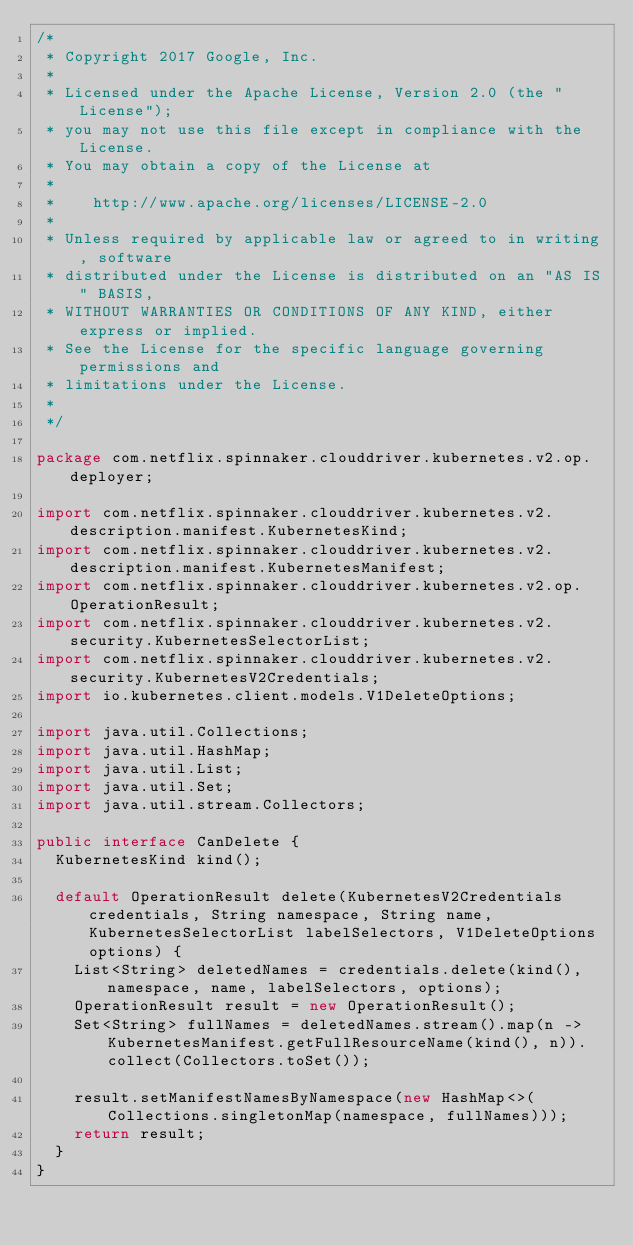Convert code to text. <code><loc_0><loc_0><loc_500><loc_500><_Java_>/*
 * Copyright 2017 Google, Inc.
 *
 * Licensed under the Apache License, Version 2.0 (the "License");
 * you may not use this file except in compliance with the License.
 * You may obtain a copy of the License at
 *
 *    http://www.apache.org/licenses/LICENSE-2.0
 *
 * Unless required by applicable law or agreed to in writing, software
 * distributed under the License is distributed on an "AS IS" BASIS,
 * WITHOUT WARRANTIES OR CONDITIONS OF ANY KIND, either express or implied.
 * See the License for the specific language governing permissions and
 * limitations under the License.
 *
 */

package com.netflix.spinnaker.clouddriver.kubernetes.v2.op.deployer;

import com.netflix.spinnaker.clouddriver.kubernetes.v2.description.manifest.KubernetesKind;
import com.netflix.spinnaker.clouddriver.kubernetes.v2.description.manifest.KubernetesManifest;
import com.netflix.spinnaker.clouddriver.kubernetes.v2.op.OperationResult;
import com.netflix.spinnaker.clouddriver.kubernetes.v2.security.KubernetesSelectorList;
import com.netflix.spinnaker.clouddriver.kubernetes.v2.security.KubernetesV2Credentials;
import io.kubernetes.client.models.V1DeleteOptions;

import java.util.Collections;
import java.util.HashMap;
import java.util.List;
import java.util.Set;
import java.util.stream.Collectors;

public interface CanDelete {
  KubernetesKind kind();

  default OperationResult delete(KubernetesV2Credentials credentials, String namespace, String name, KubernetesSelectorList labelSelectors, V1DeleteOptions options) {
    List<String> deletedNames = credentials.delete(kind(), namespace, name, labelSelectors, options);
    OperationResult result = new OperationResult();
    Set<String> fullNames = deletedNames.stream().map(n -> KubernetesManifest.getFullResourceName(kind(), n)).collect(Collectors.toSet());

    result.setManifestNamesByNamespace(new HashMap<>(Collections.singletonMap(namespace, fullNames)));
    return result;
  }
}
</code> 